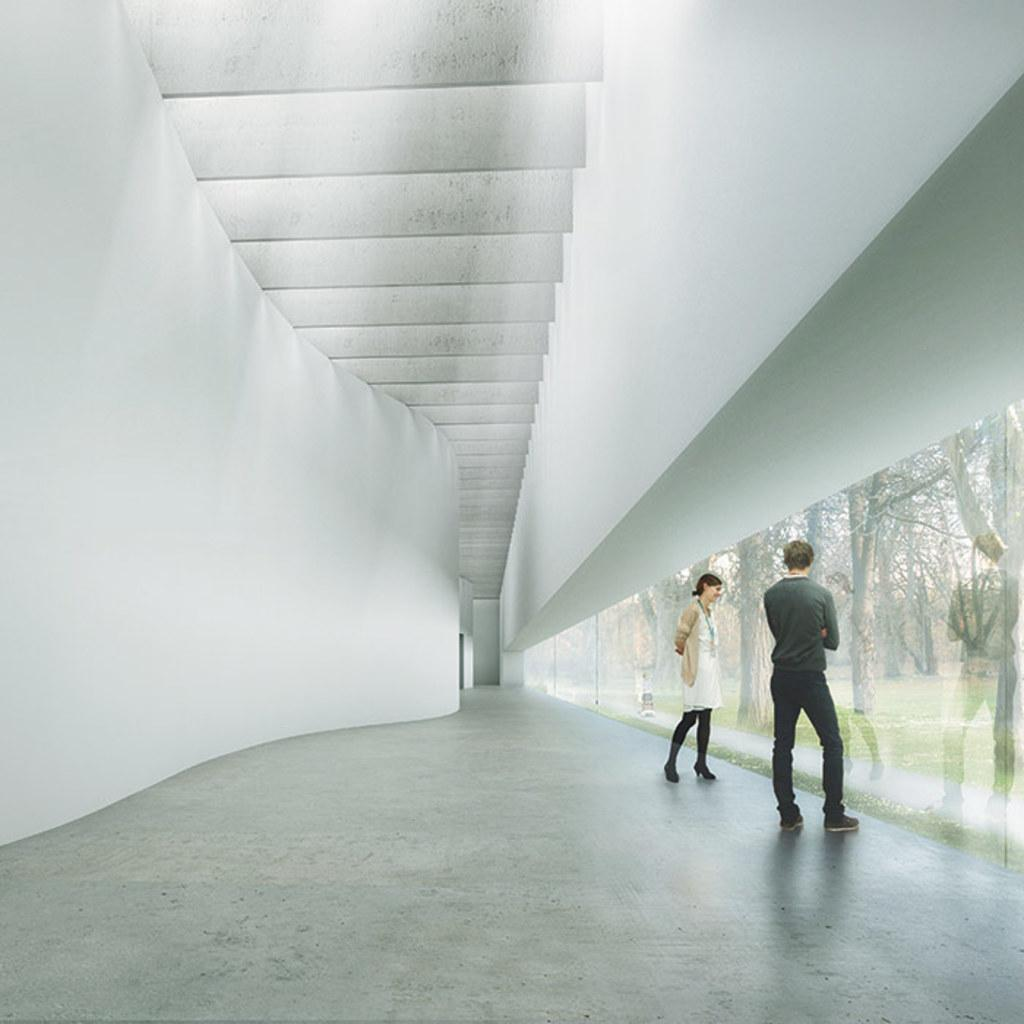How many people are present in the image? There is a man and a woman in the image. What can be seen on the right side of the image? There is a glass wall on the right side of the image, and trees are visible through it. What is on the left side of the image? There is a wall on the left side of the image. Where is the throne located in the image? There is no throne present in the image. Can you describe the tent in the image? There is no tent present in the image. 